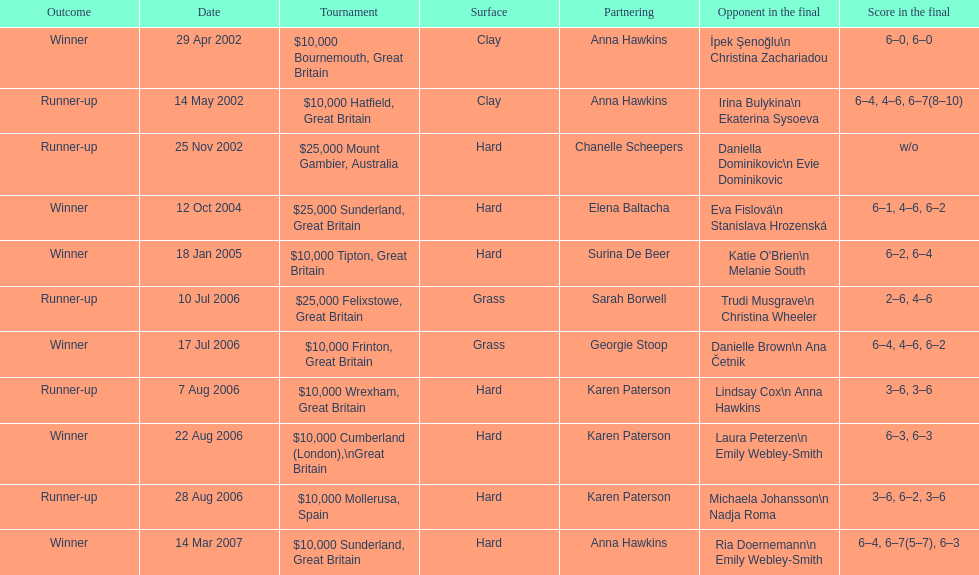Who is the person partnered with chanelle scheepers and listed above her? Anna Hawkins. 